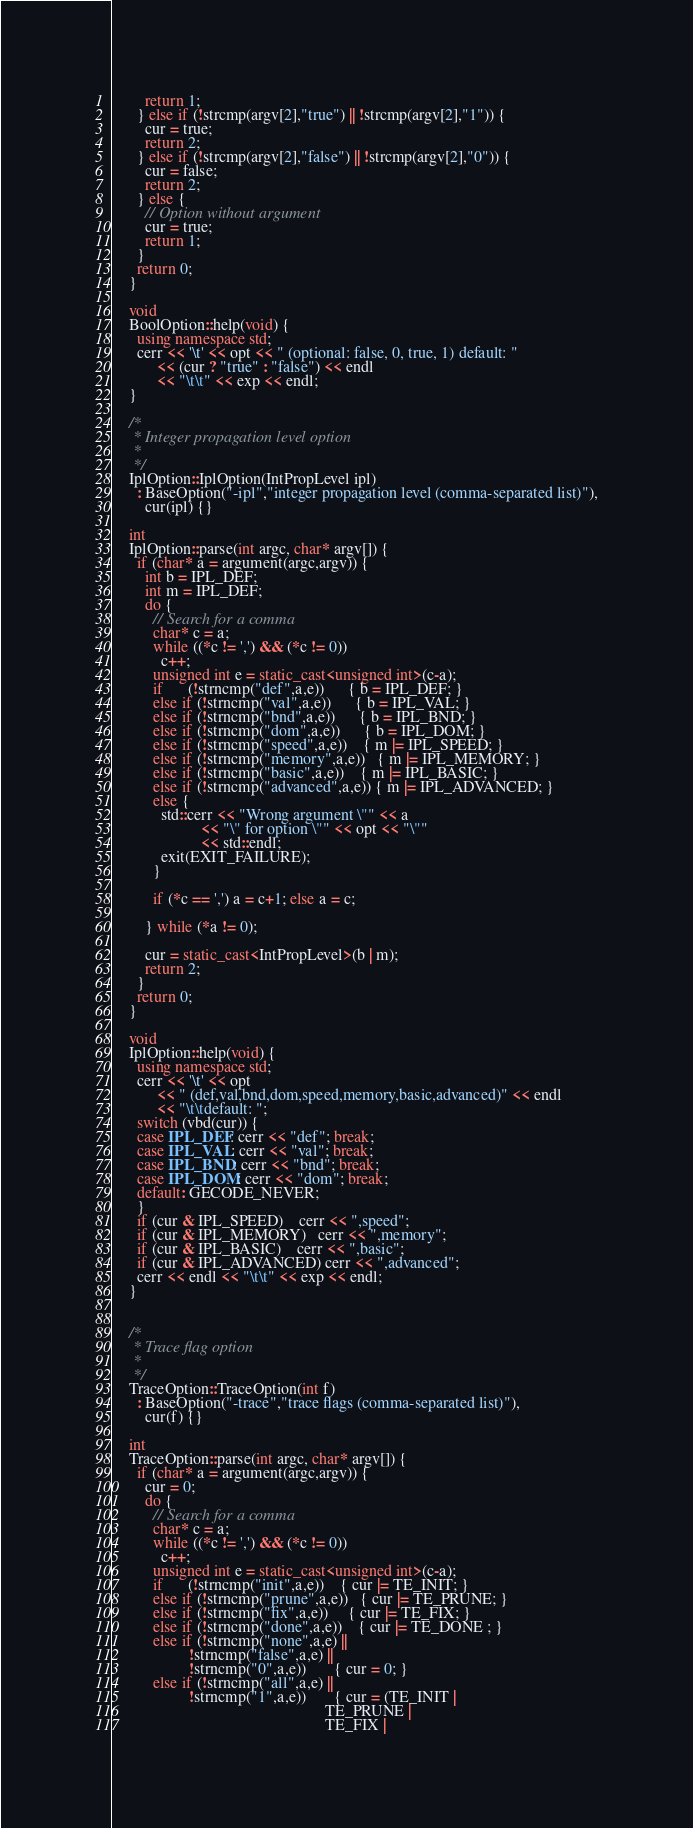Convert code to text. <code><loc_0><loc_0><loc_500><loc_500><_C++_>        return 1;
      } else if (!strcmp(argv[2],"true") || !strcmp(argv[2],"1")) {
        cur = true;
        return 2;
      } else if (!strcmp(argv[2],"false") || !strcmp(argv[2],"0")) {
        cur = false;
        return 2;
      } else {
        // Option without argument
        cur = true;
        return 1;
      }
      return 0;
    }

    void
    BoolOption::help(void) {
      using namespace std;
      cerr << '\t' << opt << " (optional: false, 0, true, 1) default: "
           << (cur ? "true" : "false") << endl
           << "\t\t" << exp << endl;
    }

    /*
     * Integer propagation level option
     *
     */
    IplOption::IplOption(IntPropLevel ipl)
      : BaseOption("-ipl","integer propagation level (comma-separated list)"),
        cur(ipl) {}

    int
    IplOption::parse(int argc, char* argv[]) {
      if (char* a = argument(argc,argv)) {
        int b = IPL_DEF;
        int m = IPL_DEF;
        do {
          // Search for a comma
          char* c = a;
          while ((*c != ',') && (*c != 0))
            c++;
          unsigned int e = static_cast<unsigned int>(c-a);
          if      (!strncmp("def",a,e))      { b = IPL_DEF; }
          else if (!strncmp("val",a,e))      { b = IPL_VAL; }
          else if (!strncmp("bnd",a,e))      { b = IPL_BND; }
          else if (!strncmp("dom",a,e))      { b = IPL_DOM; }
          else if (!strncmp("speed",a,e))    { m |= IPL_SPEED; }
          else if (!strncmp("memory",a,e))   { m |= IPL_MEMORY; }
          else if (!strncmp("basic",a,e))    { m |= IPL_BASIC; }
          else if (!strncmp("advanced",a,e)) { m |= IPL_ADVANCED; }
          else {
            std::cerr << "Wrong argument \"" << a
                      << "\" for option \"" << opt << "\""
                      << std::endl;
            exit(EXIT_FAILURE);
          }

          if (*c == ',') a = c+1; else a = c;

        } while (*a != 0);

        cur = static_cast<IntPropLevel>(b | m);
        return 2;
      }
      return 0;
    }

    void
    IplOption::help(void) {
      using namespace std;
      cerr << '\t' << opt
           << " (def,val,bnd,dom,speed,memory,basic,advanced)" << endl
           << "\t\tdefault: ";
      switch (vbd(cur)) {
      case IPL_DEF: cerr << "def"; break;
      case IPL_VAL: cerr << "val"; break;
      case IPL_BND: cerr << "bnd"; break;
      case IPL_DOM: cerr << "dom"; break;
      default: GECODE_NEVER;
      }
      if (cur & IPL_SPEED)    cerr << ",speed";
      if (cur & IPL_MEMORY)   cerr << ",memory";
      if (cur & IPL_BASIC)    cerr << ",basic";
      if (cur & IPL_ADVANCED) cerr << ",advanced";
      cerr << endl << "\t\t" << exp << endl;
    }


    /*
     * Trace flag option
     *
     */
    TraceOption::TraceOption(int f)
      : BaseOption("-trace","trace flags (comma-separated list)"),
        cur(f) {}

    int
    TraceOption::parse(int argc, char* argv[]) {
      if (char* a = argument(argc,argv)) {
        cur = 0;
        do {
          // Search for a comma
          char* c = a;
          while ((*c != ',') && (*c != 0))
            c++;
          unsigned int e = static_cast<unsigned int>(c-a);
          if      (!strncmp("init",a,e))    { cur |= TE_INIT; }
          else if (!strncmp("prune",a,e))   { cur |= TE_PRUNE; }
          else if (!strncmp("fix",a,e))     { cur |= TE_FIX; }
          else if (!strncmp("done",a,e))    { cur |= TE_DONE ; }
          else if (!strncmp("none",a,e) ||
                   !strncmp("false",a,e) ||
                   !strncmp("0",a,e))       { cur = 0; }
          else if (!strncmp("all",a,e) ||
                   !strncmp("1",a,e))       { cur = (TE_INIT |
                                                     TE_PRUNE |
                                                     TE_FIX |</code> 